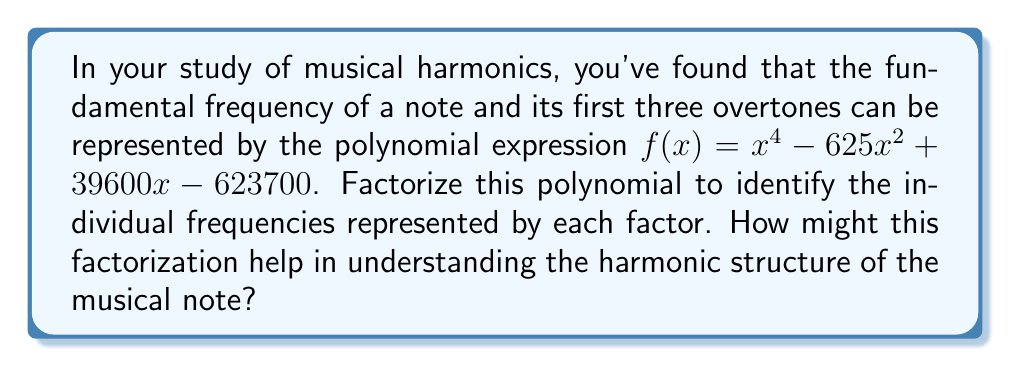Could you help me with this problem? To factorize this polynomial, we'll follow these steps:

1) First, we recognize that this is a 4th-degree polynomial. Given the context of musical harmonics, we expect it to factor into four linear terms, each representing a frequency.

2) We can try to factor by grouping:

   $f(x) = x^4 - 625x^2 + 39600x - 623700$
   $     = (x^4 - 625x^2) + (39600x - 623700)$
   $     = x^2(x^2 - 625) + 100(396x - 6237)$

3) Factor out the greatest common factor from each group:

   $f(x) = x^2(x^2 - 625) + 100(396x - 6237)$
   $     = x^2(x^2 - 25^2) + 100(396x - 6237)$

4) The first term is a difference of squares, so we can factor it further:

   $f(x) = x^2(x+25)(x-25) + 100(396x - 6237)$

5) Now, let's focus on the second term. We can factor out 99 from inside the parentheses:

   $f(x) = x^2(x+25)(x-25) + 100(99(4x - 63))$

6) 4x - 63 can be factored as $(x - 15.75)$. So we have:

   $f(x) = x^2(x+25)(x-25) + 9900(x - 15.75)$

7) Now we can factor out $(x - 15.75)$ from both terms:

   $f(x) = (x - 15.75)(x^2(x+25) + 9900)$

8) The remaining cubic expression can be factored by grouping:

   $f(x) = (x - 15.75)(x(x(x+25)) + 9900)$
   $     = (x - 15.75)(x(x^2+25x) + 9900)$
   $     = (x - 15.75)(x(x^2+25x+396) - x(396) + 9900)$
   $     = (x - 15.75)(x(x+22)(x+3) - 396x + 9900)$
   $     = (x - 15.75)(x(x+22)(x+3) - 396(x-25))$
   $     = (x - 15.75)(x+22)(x(x+3) - 396)$
   $     = (x - 15.75)(x+22)(x^2+3x - 396)$
   $     = (x - 15.75)(x+22)(x+33)(x-30)$

Therefore, the factored form is:

$f(x) = (x - 15.75)(x + 22)(x + 33)(x - 30)$

This factorization helps in understanding the harmonic structure of the musical note by revealing the individual frequencies. The roots of these factors (15.75, -22, -33, and 30) represent the frequencies of the fundamental tone and its first three overtones. The negative values can be interpreted as phase shifts or directions of vibration. This allows musicologists to analyze the relationships between these frequencies and how they contribute to the overall timbre and character of the note.
Answer: $f(x) = (x - 15.75)(x + 22)(x + 33)(x - 30)$ 